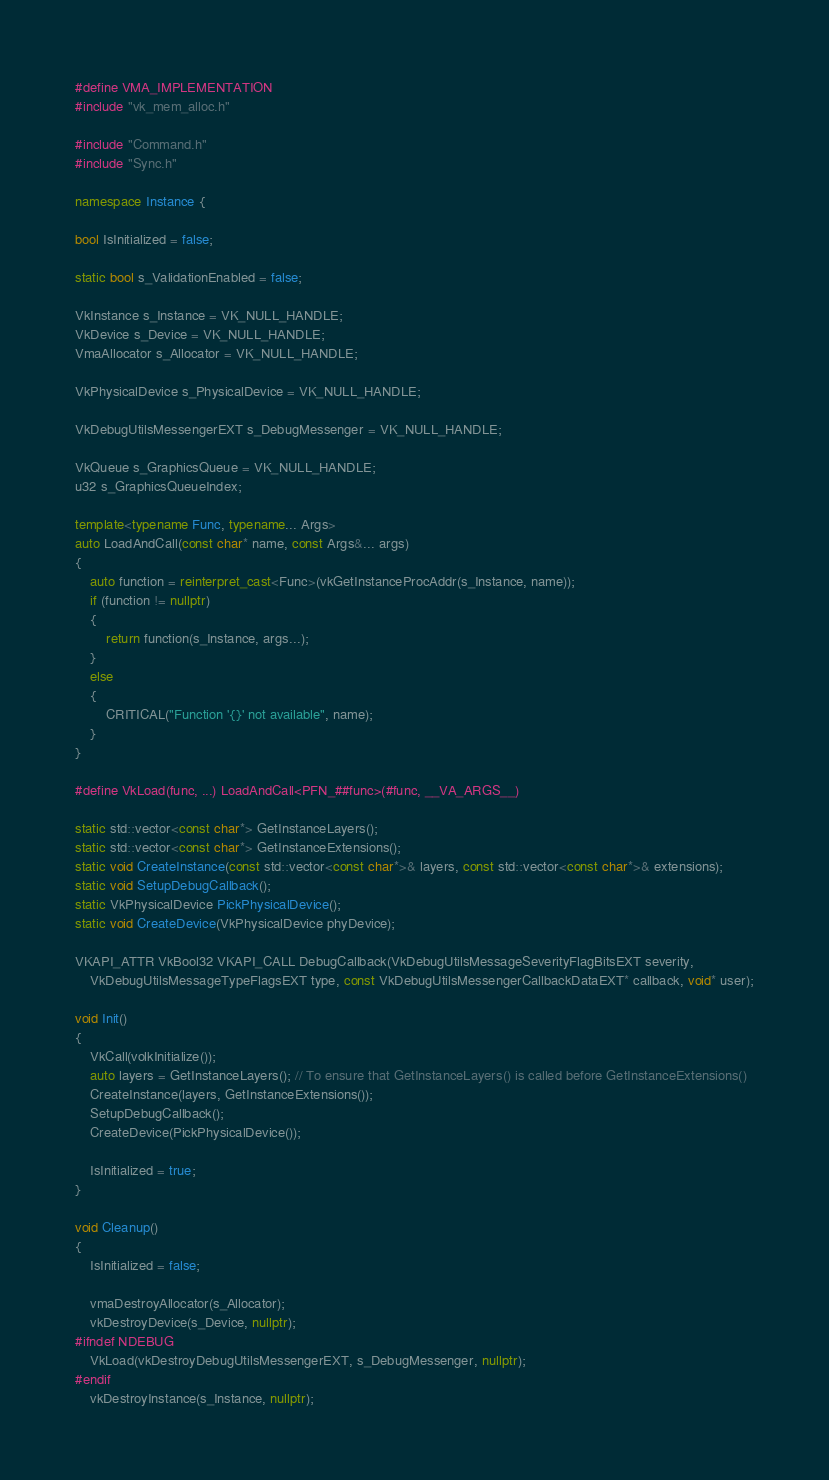Convert code to text. <code><loc_0><loc_0><loc_500><loc_500><_C++_>#define VMA_IMPLEMENTATION
#include "vk_mem_alloc.h"

#include "Command.h"
#include "Sync.h"

namespace Instance {

bool IsInitialized = false;

static bool s_ValidationEnabled = false;

VkInstance s_Instance = VK_NULL_HANDLE;
VkDevice s_Device = VK_NULL_HANDLE;
VmaAllocator s_Allocator = VK_NULL_HANDLE;

VkPhysicalDevice s_PhysicalDevice = VK_NULL_HANDLE;

VkDebugUtilsMessengerEXT s_DebugMessenger = VK_NULL_HANDLE;

VkQueue s_GraphicsQueue = VK_NULL_HANDLE;
u32 s_GraphicsQueueIndex;

template<typename Func, typename... Args>
auto LoadAndCall(const char* name, const Args&... args)
{
	auto function = reinterpret_cast<Func>(vkGetInstanceProcAddr(s_Instance, name));
	if (function != nullptr)
	{
		return function(s_Instance, args...);
	}
	else
	{
		CRITICAL("Function '{}' not available", name);
	}
}

#define VkLoad(func, ...) LoadAndCall<PFN_##func>(#func, __VA_ARGS__)

static std::vector<const char*> GetInstanceLayers();
static std::vector<const char*> GetInstanceExtensions();
static void CreateInstance(const std::vector<const char*>& layers, const std::vector<const char*>& extensions);
static void SetupDebugCallback();
static VkPhysicalDevice PickPhysicalDevice();
static void CreateDevice(VkPhysicalDevice phyDevice);

VKAPI_ATTR VkBool32 VKAPI_CALL DebugCallback(VkDebugUtilsMessageSeverityFlagBitsEXT severity,
	VkDebugUtilsMessageTypeFlagsEXT type, const VkDebugUtilsMessengerCallbackDataEXT* callback, void* user);

void Init()
{
	VkCall(volkInitialize());
	auto layers = GetInstanceLayers(); // To ensure that GetInstanceLayers() is called before GetInstanceExtensions()
	CreateInstance(layers, GetInstanceExtensions());
	SetupDebugCallback();
	CreateDevice(PickPhysicalDevice());

	IsInitialized = true;
}

void Cleanup()
{
	IsInitialized = false;

	vmaDestroyAllocator(s_Allocator);
	vkDestroyDevice(s_Device, nullptr);
#ifndef NDEBUG
	VkLoad(vkDestroyDebugUtilsMessengerEXT, s_DebugMessenger, nullptr);
#endif
	vkDestroyInstance(s_Instance, nullptr);</code> 